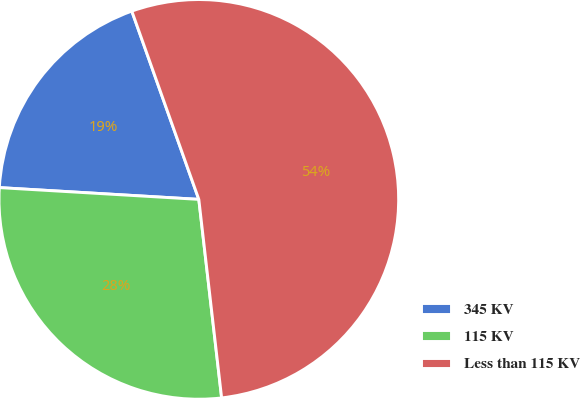Convert chart to OTSL. <chart><loc_0><loc_0><loc_500><loc_500><pie_chart><fcel>345 KV<fcel>115 KV<fcel>Less than 115 KV<nl><fcel>18.62%<fcel>27.76%<fcel>53.62%<nl></chart> 